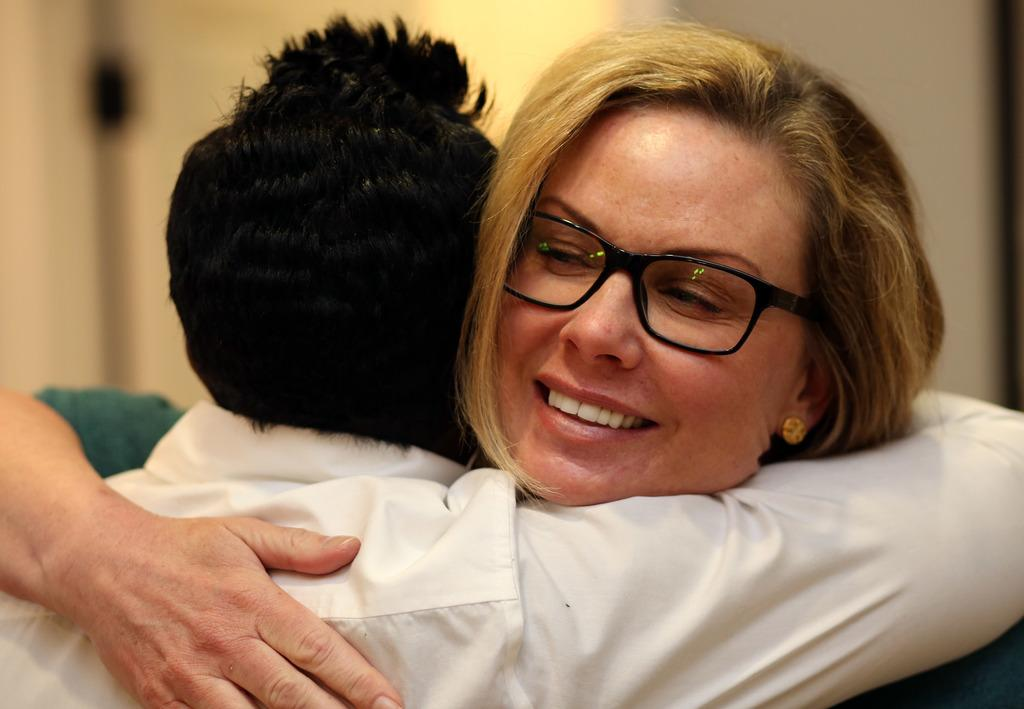What can be observed about the background of the image? The background of the picture is blurred. What are the people in the image doing? There are people hugging each other in the image. Can you describe the appearance of the woman in the image? The woman is wearing spectacles. What is the woman's expression in the image? The woman is smiling. What type of crime is being committed in the image? There is no crime being committed in the image; it features people hugging each other and a smiling woman. Can you tell me how many rabbits are present in the image? There are no rabbits present in the image. 